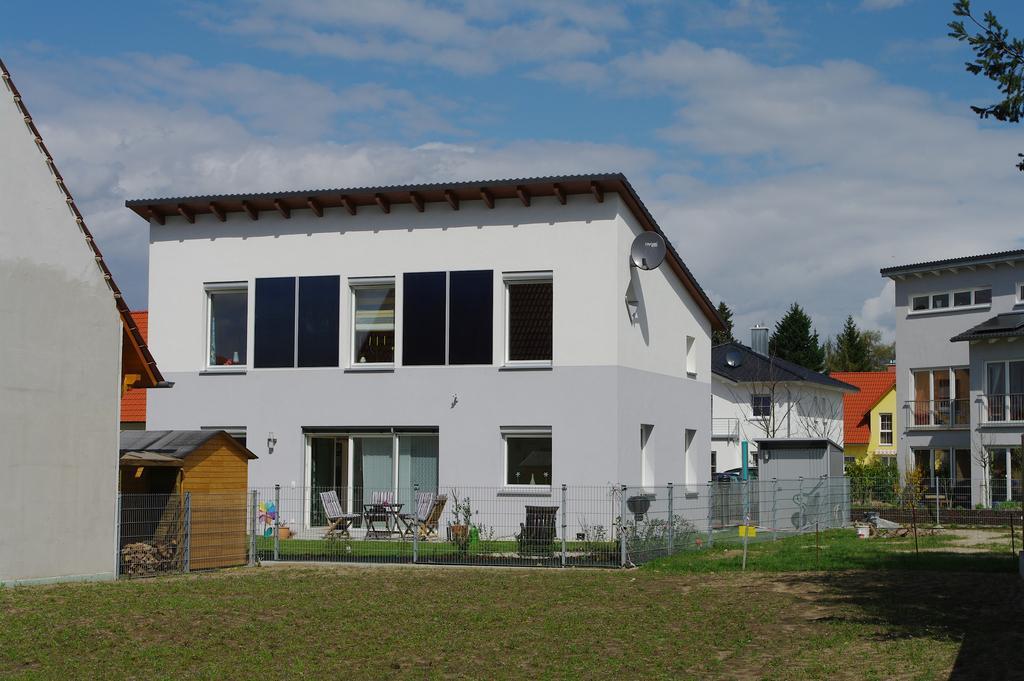In one or two sentences, can you explain what this image depicts? In this picture, we can see a few buildings with windows, houses, we can see ground with grass, trees, and we can see chairs, fencing and the sky with clouds. 